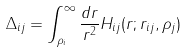<formula> <loc_0><loc_0><loc_500><loc_500>\Delta _ { i j } = \int _ { \rho _ { i } } ^ { \infty } \frac { d r } { r ^ { 2 } } H _ { i j } ( r ; r _ { i j } , \rho _ { j } )</formula> 